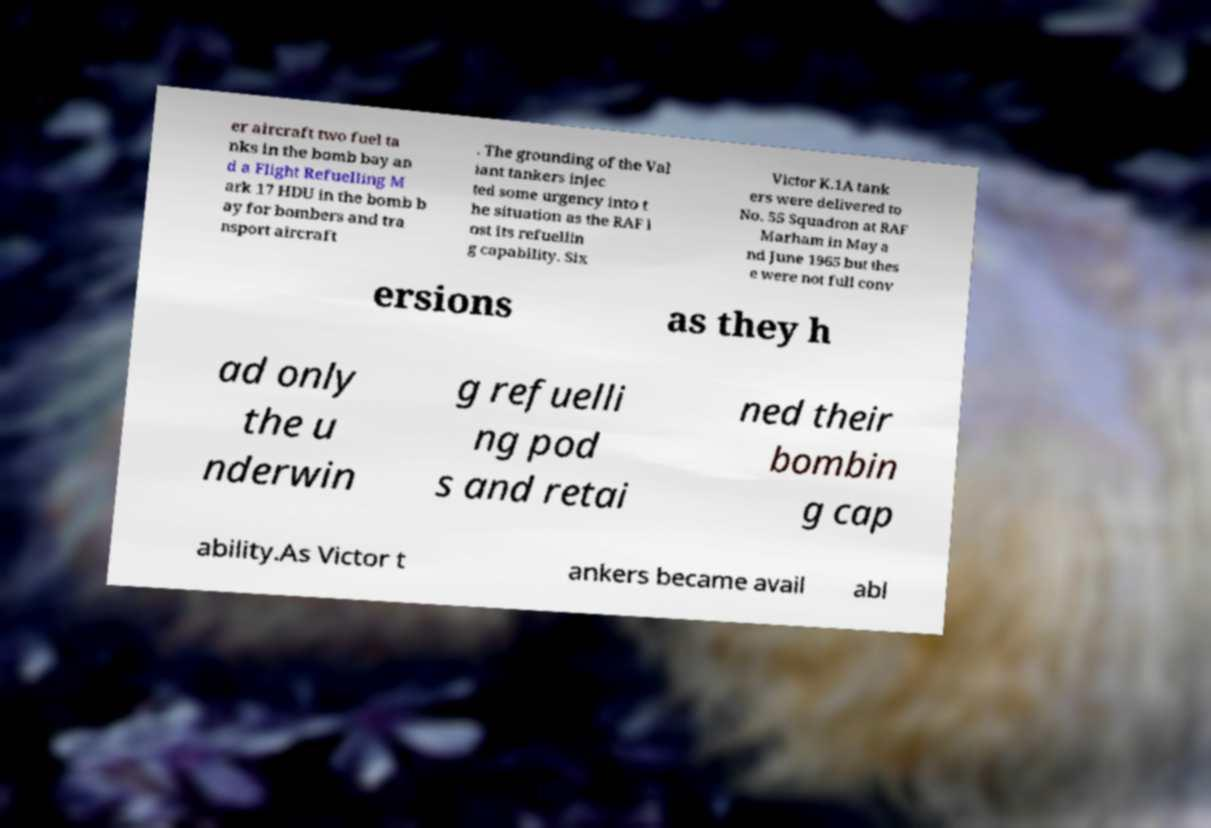Please identify and transcribe the text found in this image. er aircraft two fuel ta nks in the bomb bay an d a Flight Refuelling M ark 17 HDU in the bomb b ay for bombers and tra nsport aircraft . The grounding of the Val iant tankers injec ted some urgency into t he situation as the RAF l ost its refuellin g capability. Six Victor K.1A tank ers were delivered to No. 55 Squadron at RAF Marham in May a nd June 1965 but thes e were not full conv ersions as they h ad only the u nderwin g refuelli ng pod s and retai ned their bombin g cap ability.As Victor t ankers became avail abl 